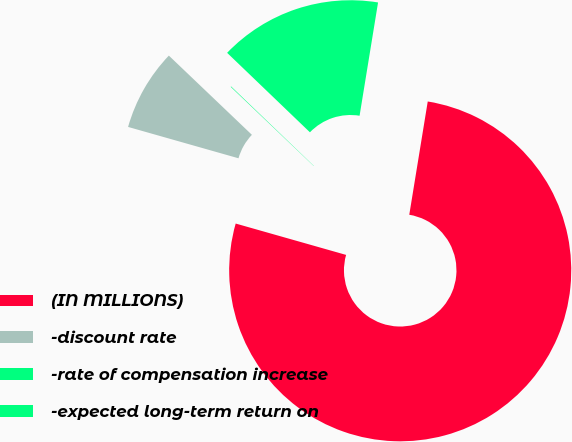Convert chart. <chart><loc_0><loc_0><loc_500><loc_500><pie_chart><fcel>(IN MILLIONS)<fcel>-discount rate<fcel>-rate of compensation increase<fcel>-expected long-term return on<nl><fcel>76.83%<fcel>7.72%<fcel>0.05%<fcel>15.4%<nl></chart> 